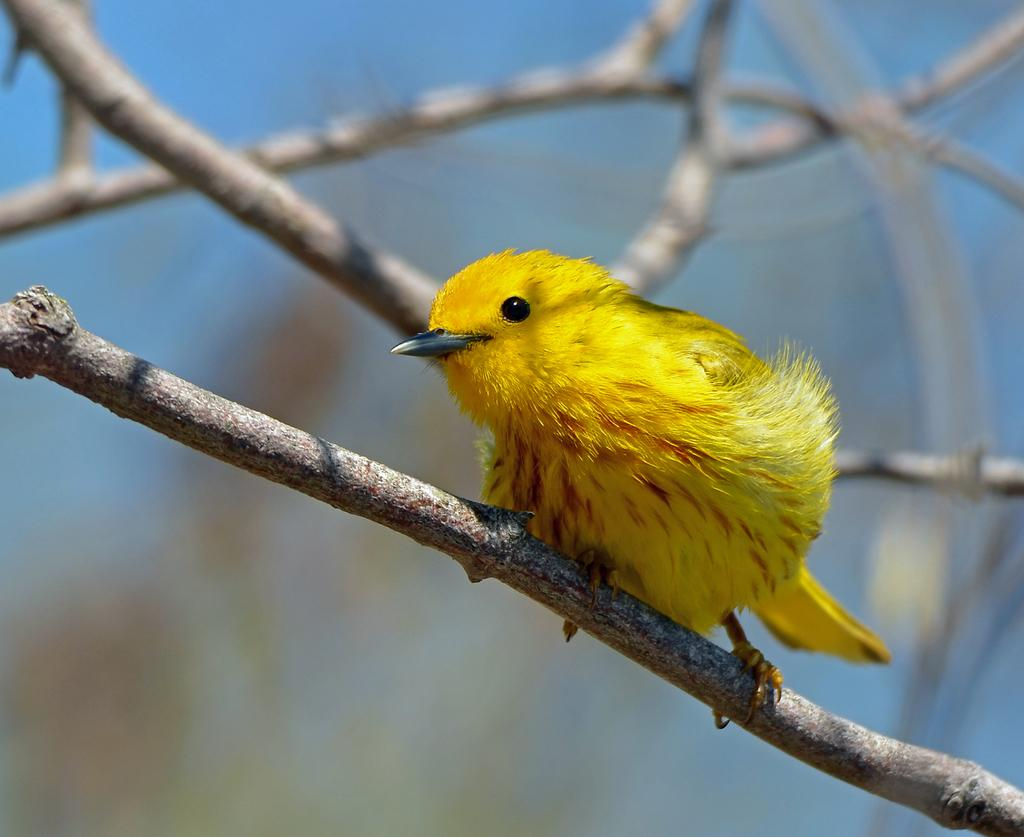What type of animal can be seen in the image? There is a bird in the image. What is the color of the bird? The bird is yellow in color. What can be seen in the background of the image? There are branches visible in the image. What is the color of the surface in the backdrop? There is a light blue color surface in the backdrop. Can you tell me how many flowers are present in the image? There are no flowers present in the image. What type of flame can be seen in the image? There is no flame present in the image. 